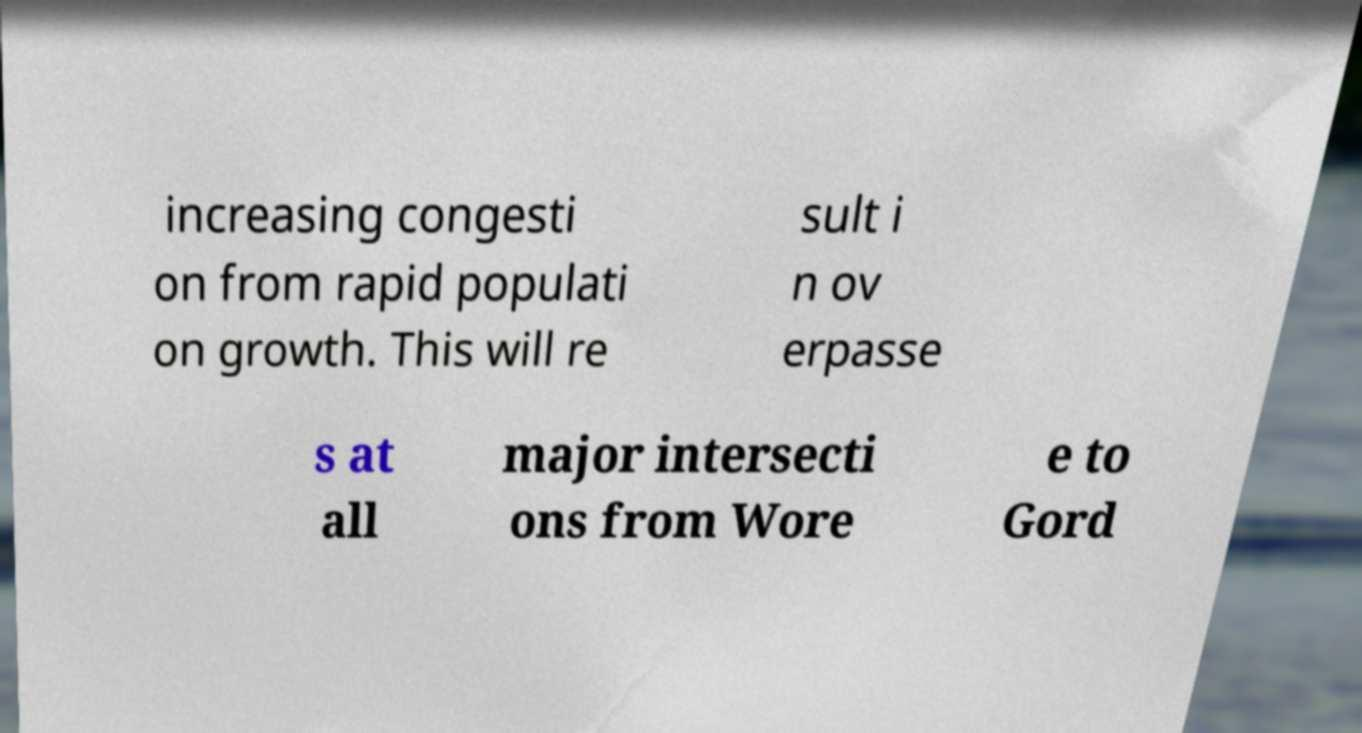Please identify and transcribe the text found in this image. increasing congesti on from rapid populati on growth. This will re sult i n ov erpasse s at all major intersecti ons from Wore e to Gord 